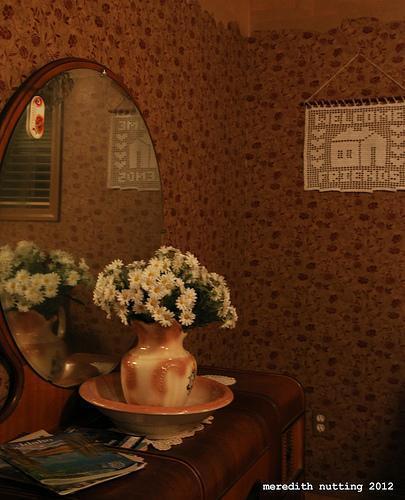How many bowls are there?
Give a very brief answer. 1. 